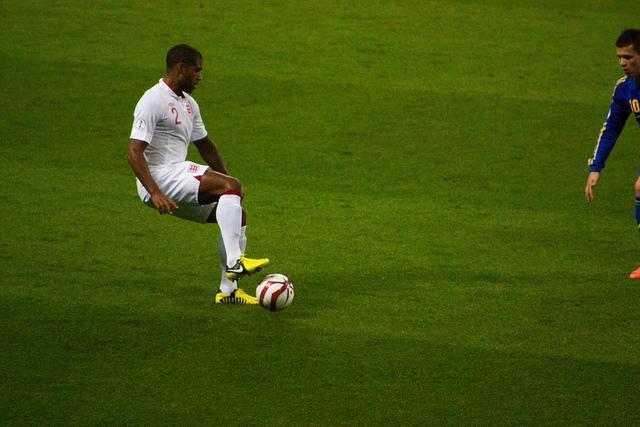The man with the ball has shoes that have a majority color that matches the color of what?
Select the accurate answer and provide justification: `Answer: choice
Rationale: srationale.`
Options: Horse, cow's tongue, mallard's bill, zebra. Answer: mallard's bill.
Rationale: A mallards bill is yellow or sometimes lighter like white. 